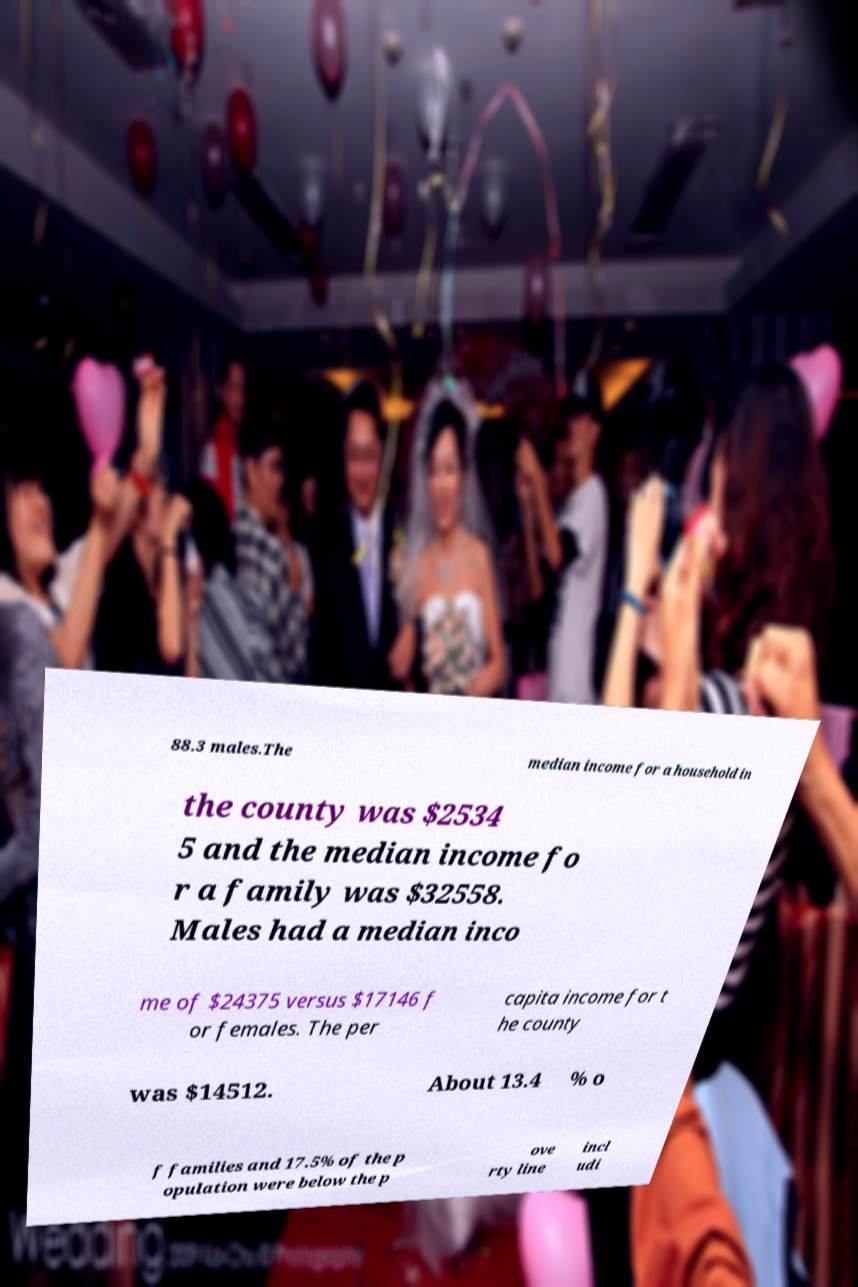There's text embedded in this image that I need extracted. Can you transcribe it verbatim? 88.3 males.The median income for a household in the county was $2534 5 and the median income fo r a family was $32558. Males had a median inco me of $24375 versus $17146 f or females. The per capita income for t he county was $14512. About 13.4 % o f families and 17.5% of the p opulation were below the p ove rty line incl udi 